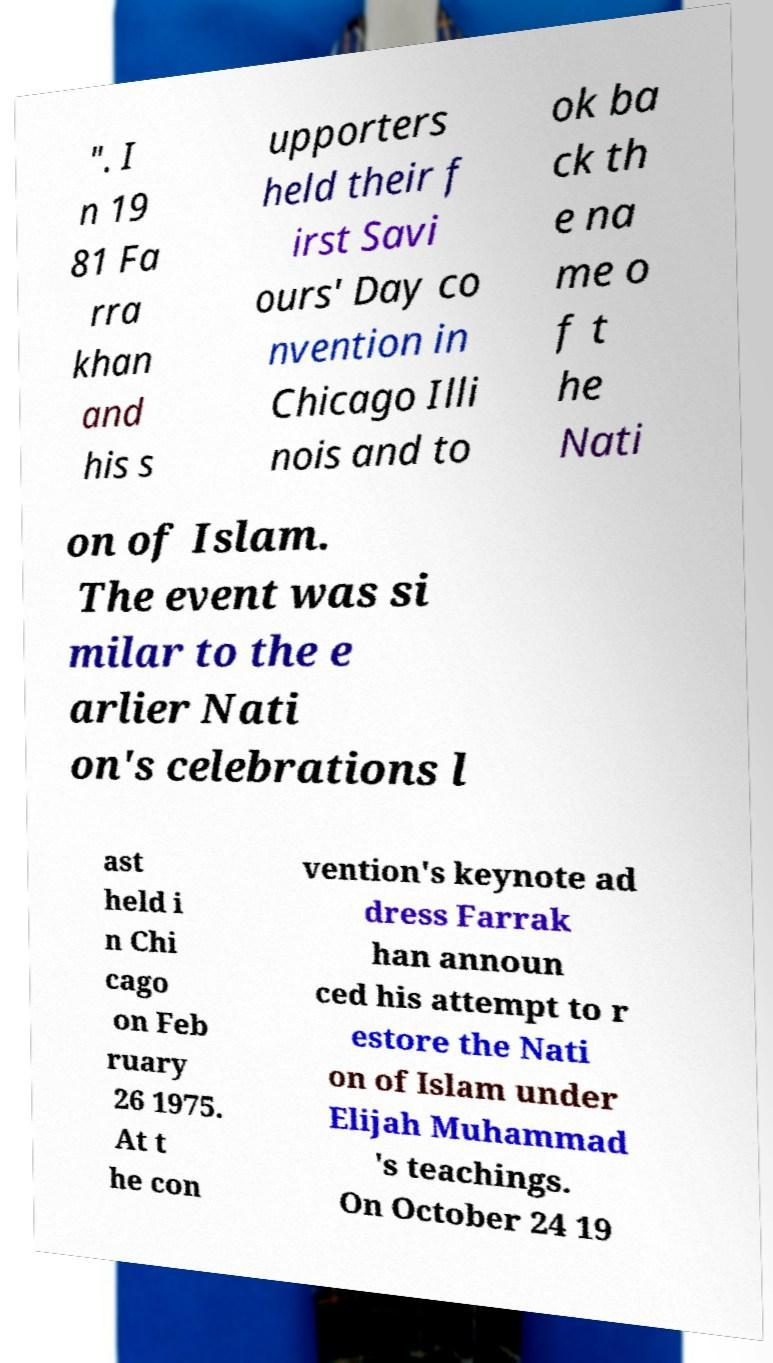Can you read and provide the text displayed in the image?This photo seems to have some interesting text. Can you extract and type it out for me? ". I n 19 81 Fa rra khan and his s upporters held their f irst Savi ours' Day co nvention in Chicago Illi nois and to ok ba ck th e na me o f t he Nati on of Islam. The event was si milar to the e arlier Nati on's celebrations l ast held i n Chi cago on Feb ruary 26 1975. At t he con vention's keynote ad dress Farrak han announ ced his attempt to r estore the Nati on of Islam under Elijah Muhammad 's teachings. On October 24 19 